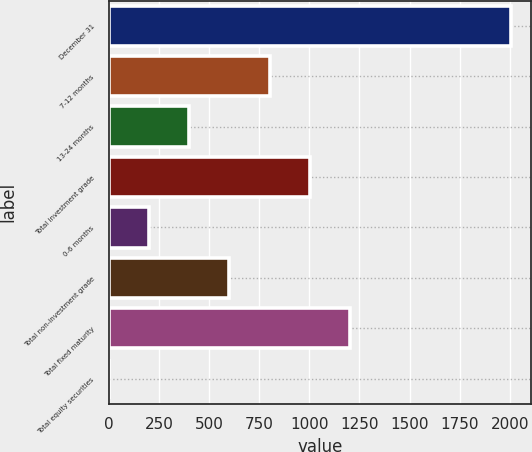Convert chart to OTSL. <chart><loc_0><loc_0><loc_500><loc_500><bar_chart><fcel>December 31<fcel>7-12 months<fcel>13-24 months<fcel>Total investment grade<fcel>0-6 months<fcel>Total non-investment grade<fcel>Total fixed maturity<fcel>Total equity securities<nl><fcel>2004<fcel>801.96<fcel>401.28<fcel>1002.3<fcel>200.94<fcel>601.62<fcel>1202.64<fcel>0.6<nl></chart> 